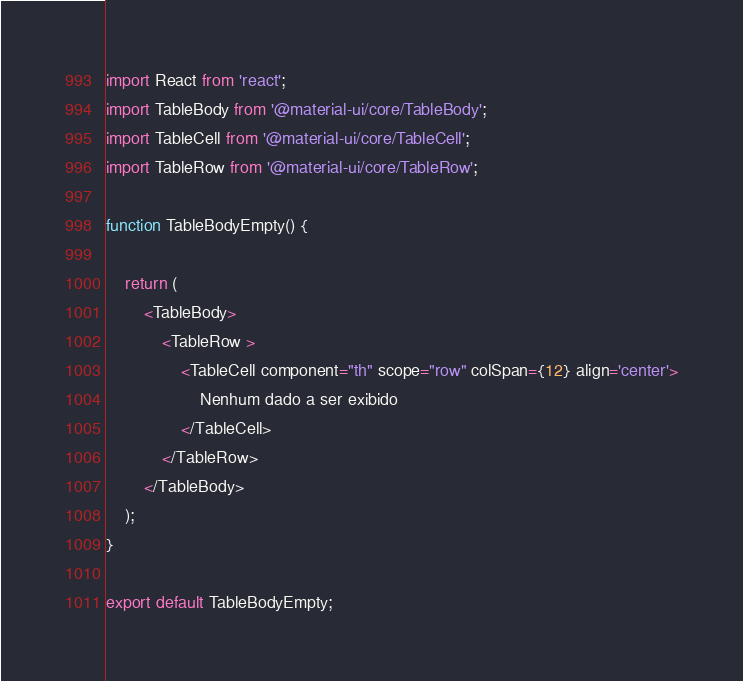Convert code to text. <code><loc_0><loc_0><loc_500><loc_500><_TypeScript_>import React from 'react';
import TableBody from '@material-ui/core/TableBody';
import TableCell from '@material-ui/core/TableCell';
import TableRow from '@material-ui/core/TableRow';

function TableBodyEmpty() {

    return (
        <TableBody>
            <TableRow >
                <TableCell component="th" scope="row" colSpan={12} align='center'>
                    Nenhum dado a ser exibido
                </TableCell>
            </TableRow>
        </TableBody>
    );
}

export default TableBodyEmpty;</code> 